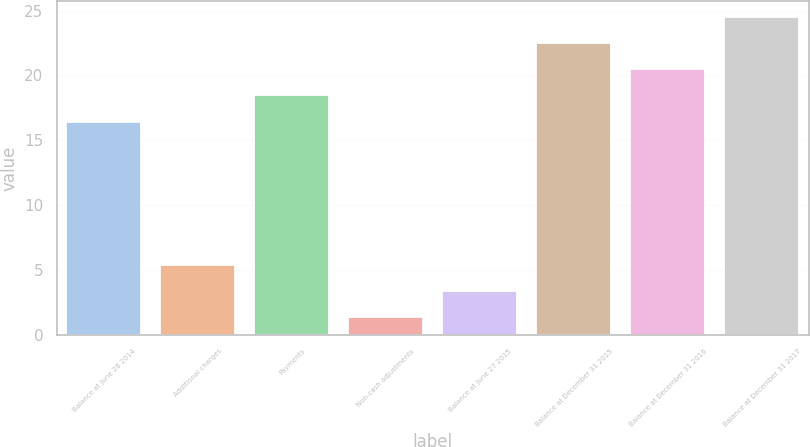Convert chart to OTSL. <chart><loc_0><loc_0><loc_500><loc_500><bar_chart><fcel>Balance at June 28 2014<fcel>Additional charges<fcel>Payments<fcel>Non-cash adjustments<fcel>Balance at June 27 2015<fcel>Balance at December 31 2015<fcel>Balance at December 31 2016<fcel>Balance at December 31 2017<nl><fcel>16.4<fcel>5.4<fcel>18.5<fcel>1.4<fcel>3.4<fcel>22.5<fcel>20.5<fcel>24.5<nl></chart> 